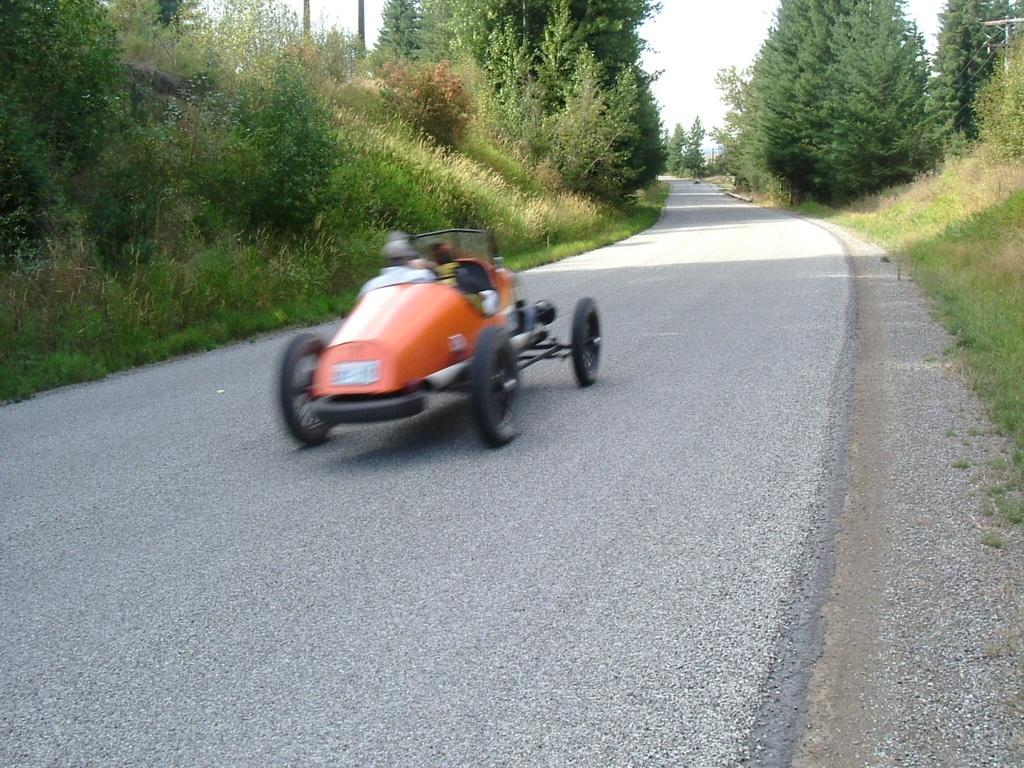What can be seen on the road in the image? There are vehicles on the road in the image. What type of natural vegetation is visible in the image? There are trees and grass visible in the image. Where is the mailbox located in the image? There is no mailbox present in the image. What type of juice is being served in the image? There is no juice or any indication of a serving activity in the image. 